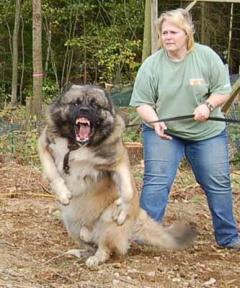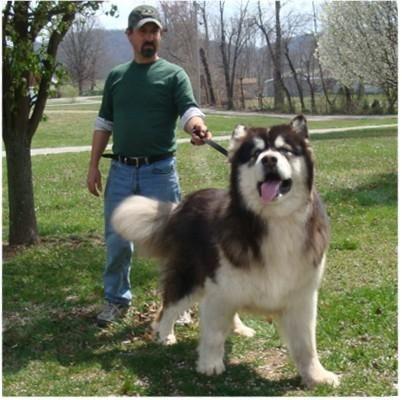The first image is the image on the left, the second image is the image on the right. Considering the images on both sides, is "There is a person in a green top standing near the dog." valid? Answer yes or no. Yes. The first image is the image on the left, the second image is the image on the right. Given the left and right images, does the statement "The right image contains at least two dogs." hold true? Answer yes or no. No. 